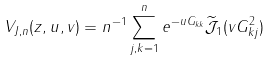<formula> <loc_0><loc_0><loc_500><loc_500>V _ { J , n } ( z , u , v ) = n ^ { - 1 } \sum _ { j , k = 1 } ^ { n } e ^ { - u G _ { k k } } \widetilde { \mathcal { J } } _ { 1 } ( v G _ { k j } ^ { 2 } )</formula> 